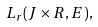<formula> <loc_0><loc_0><loc_500><loc_500>L _ { r } ( J \times R , E ) ,</formula> 